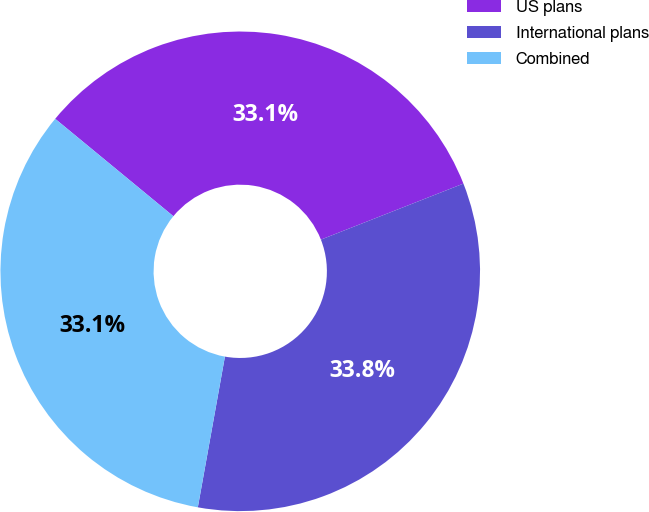<chart> <loc_0><loc_0><loc_500><loc_500><pie_chart><fcel>US plans<fcel>International plans<fcel>Combined<nl><fcel>33.07%<fcel>33.79%<fcel>33.14%<nl></chart> 